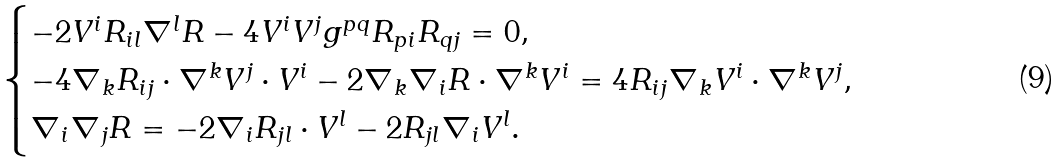Convert formula to latex. <formula><loc_0><loc_0><loc_500><loc_500>\begin{cases} - 2 V ^ { i } R _ { i l } \nabla ^ { l } R - 4 V ^ { i } V ^ { j } g ^ { p q } R _ { p i } R _ { q j } = 0 , \\ - 4 \nabla _ { k } R _ { i j } \cdot \nabla ^ { k } V ^ { j } \cdot V ^ { i } - 2 \nabla _ { k } \nabla _ { i } R \cdot \nabla ^ { k } V ^ { i } = 4 R _ { i j } \nabla _ { k } V ^ { i } \cdot \nabla ^ { k } V ^ { j } , \\ \nabla _ { i } \nabla _ { j } R = - 2 \nabla _ { i } R _ { j l } \cdot V ^ { l } - 2 R _ { j l } \nabla _ { i } V ^ { l } . \end{cases}</formula> 